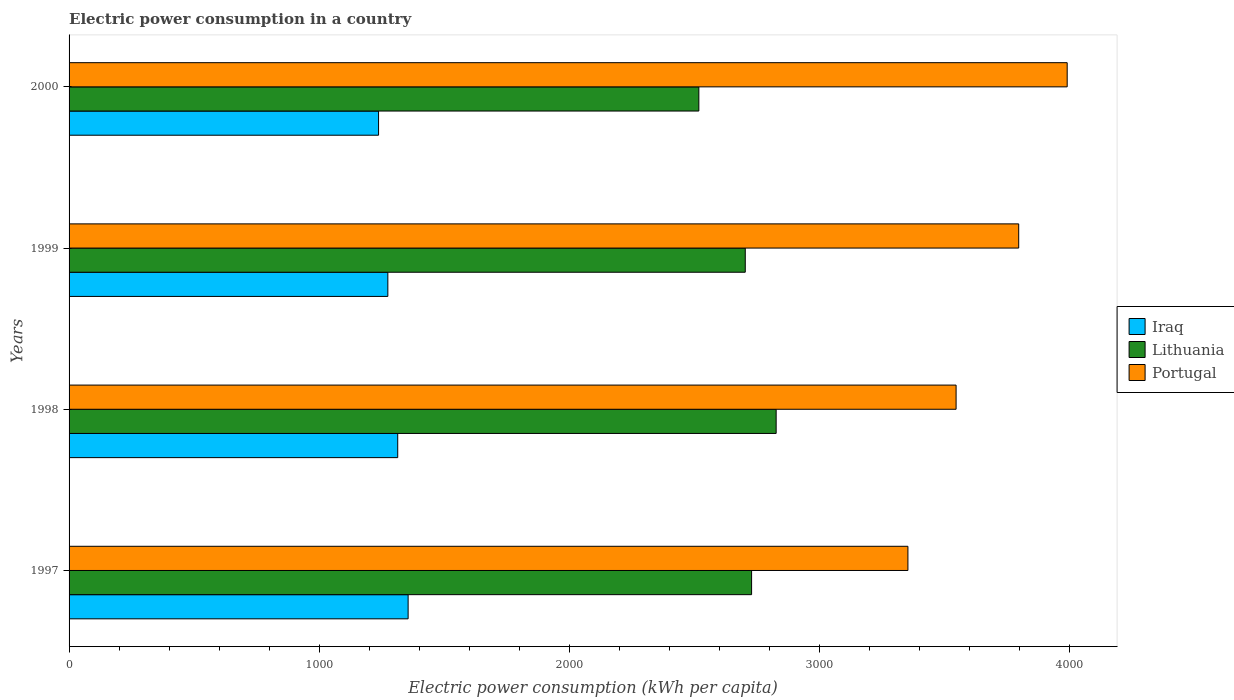How many different coloured bars are there?
Keep it short and to the point. 3. How many groups of bars are there?
Keep it short and to the point. 4. Are the number of bars on each tick of the Y-axis equal?
Your response must be concise. Yes. How many bars are there on the 3rd tick from the top?
Provide a succinct answer. 3. What is the label of the 1st group of bars from the top?
Give a very brief answer. 2000. What is the electric power consumption in in Portugal in 1997?
Keep it short and to the point. 3352.47. Across all years, what is the maximum electric power consumption in in Portugal?
Provide a short and direct response. 3988.96. Across all years, what is the minimum electric power consumption in in Lithuania?
Give a very brief answer. 2516.91. What is the total electric power consumption in in Iraq in the graph?
Ensure brevity in your answer.  5179.44. What is the difference between the electric power consumption in in Portugal in 1997 and that in 1998?
Ensure brevity in your answer.  -192.54. What is the difference between the electric power consumption in in Portugal in 2000 and the electric power consumption in in Iraq in 1998?
Keep it short and to the point. 2675.5. What is the average electric power consumption in in Iraq per year?
Provide a short and direct response. 1294.86. In the year 2000, what is the difference between the electric power consumption in in Iraq and electric power consumption in in Portugal?
Provide a short and direct response. -2752.04. In how many years, is the electric power consumption in in Iraq greater than 3400 kWh per capita?
Give a very brief answer. 0. What is the ratio of the electric power consumption in in Lithuania in 1997 to that in 1999?
Your answer should be compact. 1.01. Is the difference between the electric power consumption in in Iraq in 1997 and 2000 greater than the difference between the electric power consumption in in Portugal in 1997 and 2000?
Offer a terse response. Yes. What is the difference between the highest and the second highest electric power consumption in in Portugal?
Offer a very short reply. 193.73. What is the difference between the highest and the lowest electric power consumption in in Lithuania?
Offer a terse response. 308.98. In how many years, is the electric power consumption in in Portugal greater than the average electric power consumption in in Portugal taken over all years?
Offer a terse response. 2. Is the sum of the electric power consumption in in Iraq in 1998 and 2000 greater than the maximum electric power consumption in in Lithuania across all years?
Make the answer very short. No. What does the 3rd bar from the top in 2000 represents?
Ensure brevity in your answer.  Iraq. What does the 3rd bar from the bottom in 1998 represents?
Your response must be concise. Portugal. What is the difference between two consecutive major ticks on the X-axis?
Ensure brevity in your answer.  1000. Are the values on the major ticks of X-axis written in scientific E-notation?
Make the answer very short. No. Does the graph contain grids?
Give a very brief answer. No. How are the legend labels stacked?
Keep it short and to the point. Vertical. What is the title of the graph?
Ensure brevity in your answer.  Electric power consumption in a country. What is the label or title of the X-axis?
Make the answer very short. Electric power consumption (kWh per capita). What is the Electric power consumption (kWh per capita) of Iraq in 1997?
Keep it short and to the point. 1355.06. What is the Electric power consumption (kWh per capita) in Lithuania in 1997?
Your response must be concise. 2727.73. What is the Electric power consumption (kWh per capita) in Portugal in 1997?
Your answer should be very brief. 3352.47. What is the Electric power consumption (kWh per capita) of Iraq in 1998?
Ensure brevity in your answer.  1313.46. What is the Electric power consumption (kWh per capita) of Lithuania in 1998?
Provide a short and direct response. 2825.88. What is the Electric power consumption (kWh per capita) in Portugal in 1998?
Provide a short and direct response. 3545.01. What is the Electric power consumption (kWh per capita) in Iraq in 1999?
Provide a succinct answer. 1274. What is the Electric power consumption (kWh per capita) in Lithuania in 1999?
Ensure brevity in your answer.  2702.43. What is the Electric power consumption (kWh per capita) of Portugal in 1999?
Your answer should be very brief. 3795.23. What is the Electric power consumption (kWh per capita) in Iraq in 2000?
Offer a terse response. 1236.92. What is the Electric power consumption (kWh per capita) in Lithuania in 2000?
Offer a terse response. 2516.91. What is the Electric power consumption (kWh per capita) of Portugal in 2000?
Keep it short and to the point. 3988.96. Across all years, what is the maximum Electric power consumption (kWh per capita) of Iraq?
Your answer should be compact. 1355.06. Across all years, what is the maximum Electric power consumption (kWh per capita) in Lithuania?
Your response must be concise. 2825.88. Across all years, what is the maximum Electric power consumption (kWh per capita) of Portugal?
Your response must be concise. 3988.96. Across all years, what is the minimum Electric power consumption (kWh per capita) in Iraq?
Keep it short and to the point. 1236.92. Across all years, what is the minimum Electric power consumption (kWh per capita) of Lithuania?
Your answer should be very brief. 2516.91. Across all years, what is the minimum Electric power consumption (kWh per capita) of Portugal?
Provide a succinct answer. 3352.47. What is the total Electric power consumption (kWh per capita) of Iraq in the graph?
Ensure brevity in your answer.  5179.44. What is the total Electric power consumption (kWh per capita) in Lithuania in the graph?
Make the answer very short. 1.08e+04. What is the total Electric power consumption (kWh per capita) in Portugal in the graph?
Ensure brevity in your answer.  1.47e+04. What is the difference between the Electric power consumption (kWh per capita) in Iraq in 1997 and that in 1998?
Your answer should be very brief. 41.59. What is the difference between the Electric power consumption (kWh per capita) of Lithuania in 1997 and that in 1998?
Provide a succinct answer. -98.16. What is the difference between the Electric power consumption (kWh per capita) of Portugal in 1997 and that in 1998?
Your answer should be very brief. -192.54. What is the difference between the Electric power consumption (kWh per capita) in Iraq in 1997 and that in 1999?
Provide a short and direct response. 81.06. What is the difference between the Electric power consumption (kWh per capita) in Lithuania in 1997 and that in 1999?
Offer a terse response. 25.3. What is the difference between the Electric power consumption (kWh per capita) of Portugal in 1997 and that in 1999?
Your answer should be very brief. -442.76. What is the difference between the Electric power consumption (kWh per capita) in Iraq in 1997 and that in 2000?
Your answer should be very brief. 118.14. What is the difference between the Electric power consumption (kWh per capita) in Lithuania in 1997 and that in 2000?
Offer a very short reply. 210.82. What is the difference between the Electric power consumption (kWh per capita) in Portugal in 1997 and that in 2000?
Your answer should be compact. -636.5. What is the difference between the Electric power consumption (kWh per capita) of Iraq in 1998 and that in 1999?
Your response must be concise. 39.47. What is the difference between the Electric power consumption (kWh per capita) in Lithuania in 1998 and that in 1999?
Offer a terse response. 123.46. What is the difference between the Electric power consumption (kWh per capita) in Portugal in 1998 and that in 1999?
Give a very brief answer. -250.22. What is the difference between the Electric power consumption (kWh per capita) in Iraq in 1998 and that in 2000?
Offer a very short reply. 76.55. What is the difference between the Electric power consumption (kWh per capita) of Lithuania in 1998 and that in 2000?
Your answer should be very brief. 308.98. What is the difference between the Electric power consumption (kWh per capita) in Portugal in 1998 and that in 2000?
Your answer should be very brief. -443.95. What is the difference between the Electric power consumption (kWh per capita) in Iraq in 1999 and that in 2000?
Your response must be concise. 37.08. What is the difference between the Electric power consumption (kWh per capita) in Lithuania in 1999 and that in 2000?
Offer a very short reply. 185.52. What is the difference between the Electric power consumption (kWh per capita) in Portugal in 1999 and that in 2000?
Ensure brevity in your answer.  -193.73. What is the difference between the Electric power consumption (kWh per capita) of Iraq in 1997 and the Electric power consumption (kWh per capita) of Lithuania in 1998?
Provide a succinct answer. -1470.83. What is the difference between the Electric power consumption (kWh per capita) of Iraq in 1997 and the Electric power consumption (kWh per capita) of Portugal in 1998?
Offer a terse response. -2189.95. What is the difference between the Electric power consumption (kWh per capita) of Lithuania in 1997 and the Electric power consumption (kWh per capita) of Portugal in 1998?
Provide a short and direct response. -817.28. What is the difference between the Electric power consumption (kWh per capita) in Iraq in 1997 and the Electric power consumption (kWh per capita) in Lithuania in 1999?
Provide a succinct answer. -1347.37. What is the difference between the Electric power consumption (kWh per capita) of Iraq in 1997 and the Electric power consumption (kWh per capita) of Portugal in 1999?
Keep it short and to the point. -2440.17. What is the difference between the Electric power consumption (kWh per capita) in Lithuania in 1997 and the Electric power consumption (kWh per capita) in Portugal in 1999?
Ensure brevity in your answer.  -1067.5. What is the difference between the Electric power consumption (kWh per capita) in Iraq in 1997 and the Electric power consumption (kWh per capita) in Lithuania in 2000?
Your answer should be compact. -1161.85. What is the difference between the Electric power consumption (kWh per capita) of Iraq in 1997 and the Electric power consumption (kWh per capita) of Portugal in 2000?
Give a very brief answer. -2633.9. What is the difference between the Electric power consumption (kWh per capita) of Lithuania in 1997 and the Electric power consumption (kWh per capita) of Portugal in 2000?
Keep it short and to the point. -1261.23. What is the difference between the Electric power consumption (kWh per capita) in Iraq in 1998 and the Electric power consumption (kWh per capita) in Lithuania in 1999?
Offer a very short reply. -1388.96. What is the difference between the Electric power consumption (kWh per capita) of Iraq in 1998 and the Electric power consumption (kWh per capita) of Portugal in 1999?
Keep it short and to the point. -2481.77. What is the difference between the Electric power consumption (kWh per capita) of Lithuania in 1998 and the Electric power consumption (kWh per capita) of Portugal in 1999?
Provide a short and direct response. -969.34. What is the difference between the Electric power consumption (kWh per capita) in Iraq in 1998 and the Electric power consumption (kWh per capita) in Lithuania in 2000?
Provide a short and direct response. -1203.44. What is the difference between the Electric power consumption (kWh per capita) of Iraq in 1998 and the Electric power consumption (kWh per capita) of Portugal in 2000?
Offer a very short reply. -2675.5. What is the difference between the Electric power consumption (kWh per capita) in Lithuania in 1998 and the Electric power consumption (kWh per capita) in Portugal in 2000?
Your answer should be compact. -1163.08. What is the difference between the Electric power consumption (kWh per capita) of Iraq in 1999 and the Electric power consumption (kWh per capita) of Lithuania in 2000?
Offer a terse response. -1242.91. What is the difference between the Electric power consumption (kWh per capita) of Iraq in 1999 and the Electric power consumption (kWh per capita) of Portugal in 2000?
Your answer should be compact. -2714.96. What is the difference between the Electric power consumption (kWh per capita) of Lithuania in 1999 and the Electric power consumption (kWh per capita) of Portugal in 2000?
Your answer should be very brief. -1286.53. What is the average Electric power consumption (kWh per capita) in Iraq per year?
Ensure brevity in your answer.  1294.86. What is the average Electric power consumption (kWh per capita) in Lithuania per year?
Keep it short and to the point. 2693.24. What is the average Electric power consumption (kWh per capita) in Portugal per year?
Ensure brevity in your answer.  3670.42. In the year 1997, what is the difference between the Electric power consumption (kWh per capita) in Iraq and Electric power consumption (kWh per capita) in Lithuania?
Ensure brevity in your answer.  -1372.67. In the year 1997, what is the difference between the Electric power consumption (kWh per capita) of Iraq and Electric power consumption (kWh per capita) of Portugal?
Your answer should be compact. -1997.41. In the year 1997, what is the difference between the Electric power consumption (kWh per capita) of Lithuania and Electric power consumption (kWh per capita) of Portugal?
Provide a short and direct response. -624.74. In the year 1998, what is the difference between the Electric power consumption (kWh per capita) in Iraq and Electric power consumption (kWh per capita) in Lithuania?
Offer a very short reply. -1512.42. In the year 1998, what is the difference between the Electric power consumption (kWh per capita) in Iraq and Electric power consumption (kWh per capita) in Portugal?
Give a very brief answer. -2231.55. In the year 1998, what is the difference between the Electric power consumption (kWh per capita) of Lithuania and Electric power consumption (kWh per capita) of Portugal?
Offer a very short reply. -719.13. In the year 1999, what is the difference between the Electric power consumption (kWh per capita) in Iraq and Electric power consumption (kWh per capita) in Lithuania?
Make the answer very short. -1428.43. In the year 1999, what is the difference between the Electric power consumption (kWh per capita) in Iraq and Electric power consumption (kWh per capita) in Portugal?
Ensure brevity in your answer.  -2521.23. In the year 1999, what is the difference between the Electric power consumption (kWh per capita) of Lithuania and Electric power consumption (kWh per capita) of Portugal?
Ensure brevity in your answer.  -1092.8. In the year 2000, what is the difference between the Electric power consumption (kWh per capita) of Iraq and Electric power consumption (kWh per capita) of Lithuania?
Your response must be concise. -1279.99. In the year 2000, what is the difference between the Electric power consumption (kWh per capita) of Iraq and Electric power consumption (kWh per capita) of Portugal?
Keep it short and to the point. -2752.04. In the year 2000, what is the difference between the Electric power consumption (kWh per capita) of Lithuania and Electric power consumption (kWh per capita) of Portugal?
Your response must be concise. -1472.06. What is the ratio of the Electric power consumption (kWh per capita) of Iraq in 1997 to that in 1998?
Provide a succinct answer. 1.03. What is the ratio of the Electric power consumption (kWh per capita) in Lithuania in 1997 to that in 1998?
Offer a terse response. 0.97. What is the ratio of the Electric power consumption (kWh per capita) of Portugal in 1997 to that in 1998?
Your answer should be very brief. 0.95. What is the ratio of the Electric power consumption (kWh per capita) in Iraq in 1997 to that in 1999?
Offer a very short reply. 1.06. What is the ratio of the Electric power consumption (kWh per capita) in Lithuania in 1997 to that in 1999?
Your answer should be very brief. 1.01. What is the ratio of the Electric power consumption (kWh per capita) in Portugal in 1997 to that in 1999?
Offer a very short reply. 0.88. What is the ratio of the Electric power consumption (kWh per capita) of Iraq in 1997 to that in 2000?
Keep it short and to the point. 1.1. What is the ratio of the Electric power consumption (kWh per capita) in Lithuania in 1997 to that in 2000?
Keep it short and to the point. 1.08. What is the ratio of the Electric power consumption (kWh per capita) in Portugal in 1997 to that in 2000?
Offer a very short reply. 0.84. What is the ratio of the Electric power consumption (kWh per capita) of Iraq in 1998 to that in 1999?
Keep it short and to the point. 1.03. What is the ratio of the Electric power consumption (kWh per capita) in Lithuania in 1998 to that in 1999?
Your response must be concise. 1.05. What is the ratio of the Electric power consumption (kWh per capita) of Portugal in 1998 to that in 1999?
Give a very brief answer. 0.93. What is the ratio of the Electric power consumption (kWh per capita) in Iraq in 1998 to that in 2000?
Make the answer very short. 1.06. What is the ratio of the Electric power consumption (kWh per capita) in Lithuania in 1998 to that in 2000?
Ensure brevity in your answer.  1.12. What is the ratio of the Electric power consumption (kWh per capita) in Portugal in 1998 to that in 2000?
Offer a very short reply. 0.89. What is the ratio of the Electric power consumption (kWh per capita) in Lithuania in 1999 to that in 2000?
Provide a short and direct response. 1.07. What is the ratio of the Electric power consumption (kWh per capita) in Portugal in 1999 to that in 2000?
Offer a terse response. 0.95. What is the difference between the highest and the second highest Electric power consumption (kWh per capita) of Iraq?
Offer a very short reply. 41.59. What is the difference between the highest and the second highest Electric power consumption (kWh per capita) of Lithuania?
Make the answer very short. 98.16. What is the difference between the highest and the second highest Electric power consumption (kWh per capita) of Portugal?
Make the answer very short. 193.73. What is the difference between the highest and the lowest Electric power consumption (kWh per capita) of Iraq?
Offer a terse response. 118.14. What is the difference between the highest and the lowest Electric power consumption (kWh per capita) of Lithuania?
Make the answer very short. 308.98. What is the difference between the highest and the lowest Electric power consumption (kWh per capita) in Portugal?
Your response must be concise. 636.5. 